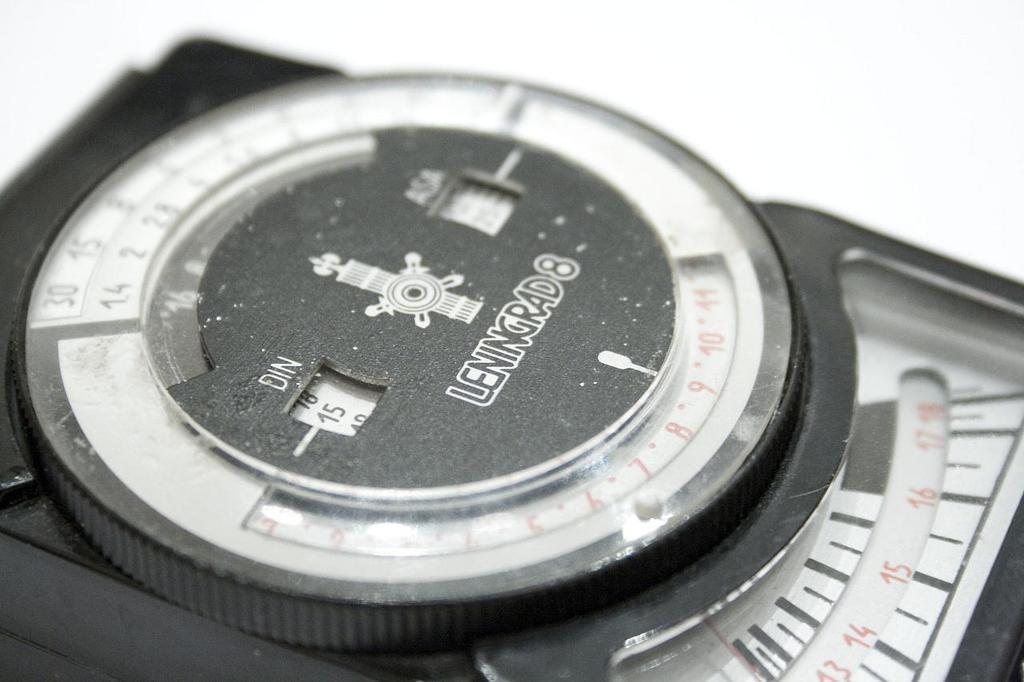<image>
Share a concise interpretation of the image provided. A device has the brand name Leningrad 8 on the front. 